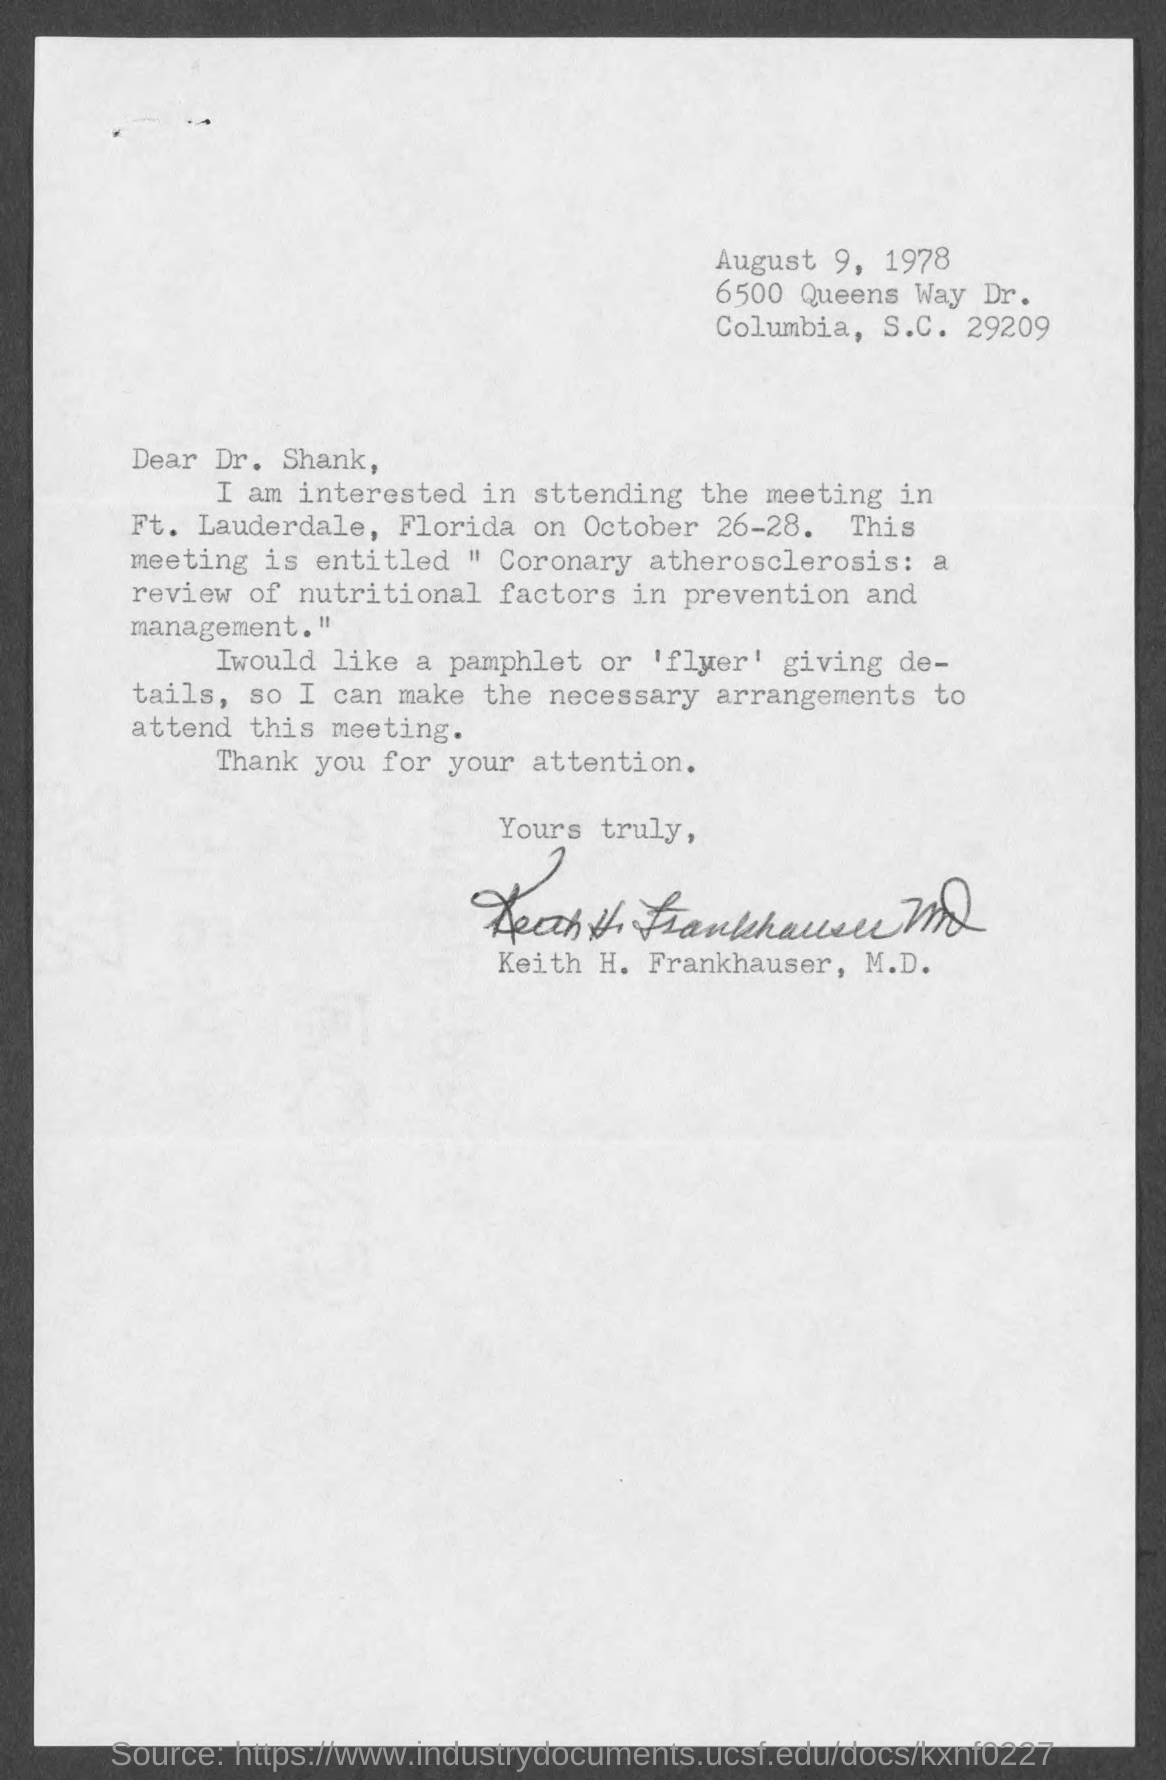Identify some key points in this picture. The date mentioned at the top of the document is August 9, 1978. The memorandum is addressed to Dr. Shank. 